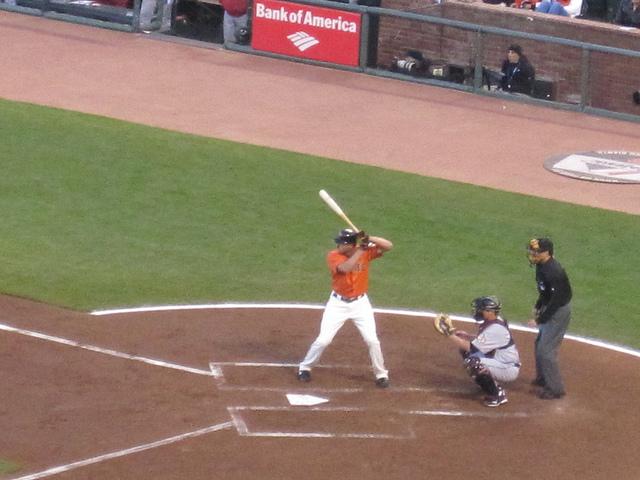What position is the man in orange playing?
Give a very brief answer. Batter. What is the name of the bank advertised in the background?
Be succinct. Bank of america. What teams are playing?
Quick response, please. Orange team. Are there any sponsor names in the photo?
Answer briefly. Yes. 